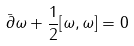<formula> <loc_0><loc_0><loc_500><loc_500>\bar { \partial } \omega + \frac { 1 } { 2 } [ \omega , \omega ] = 0</formula> 